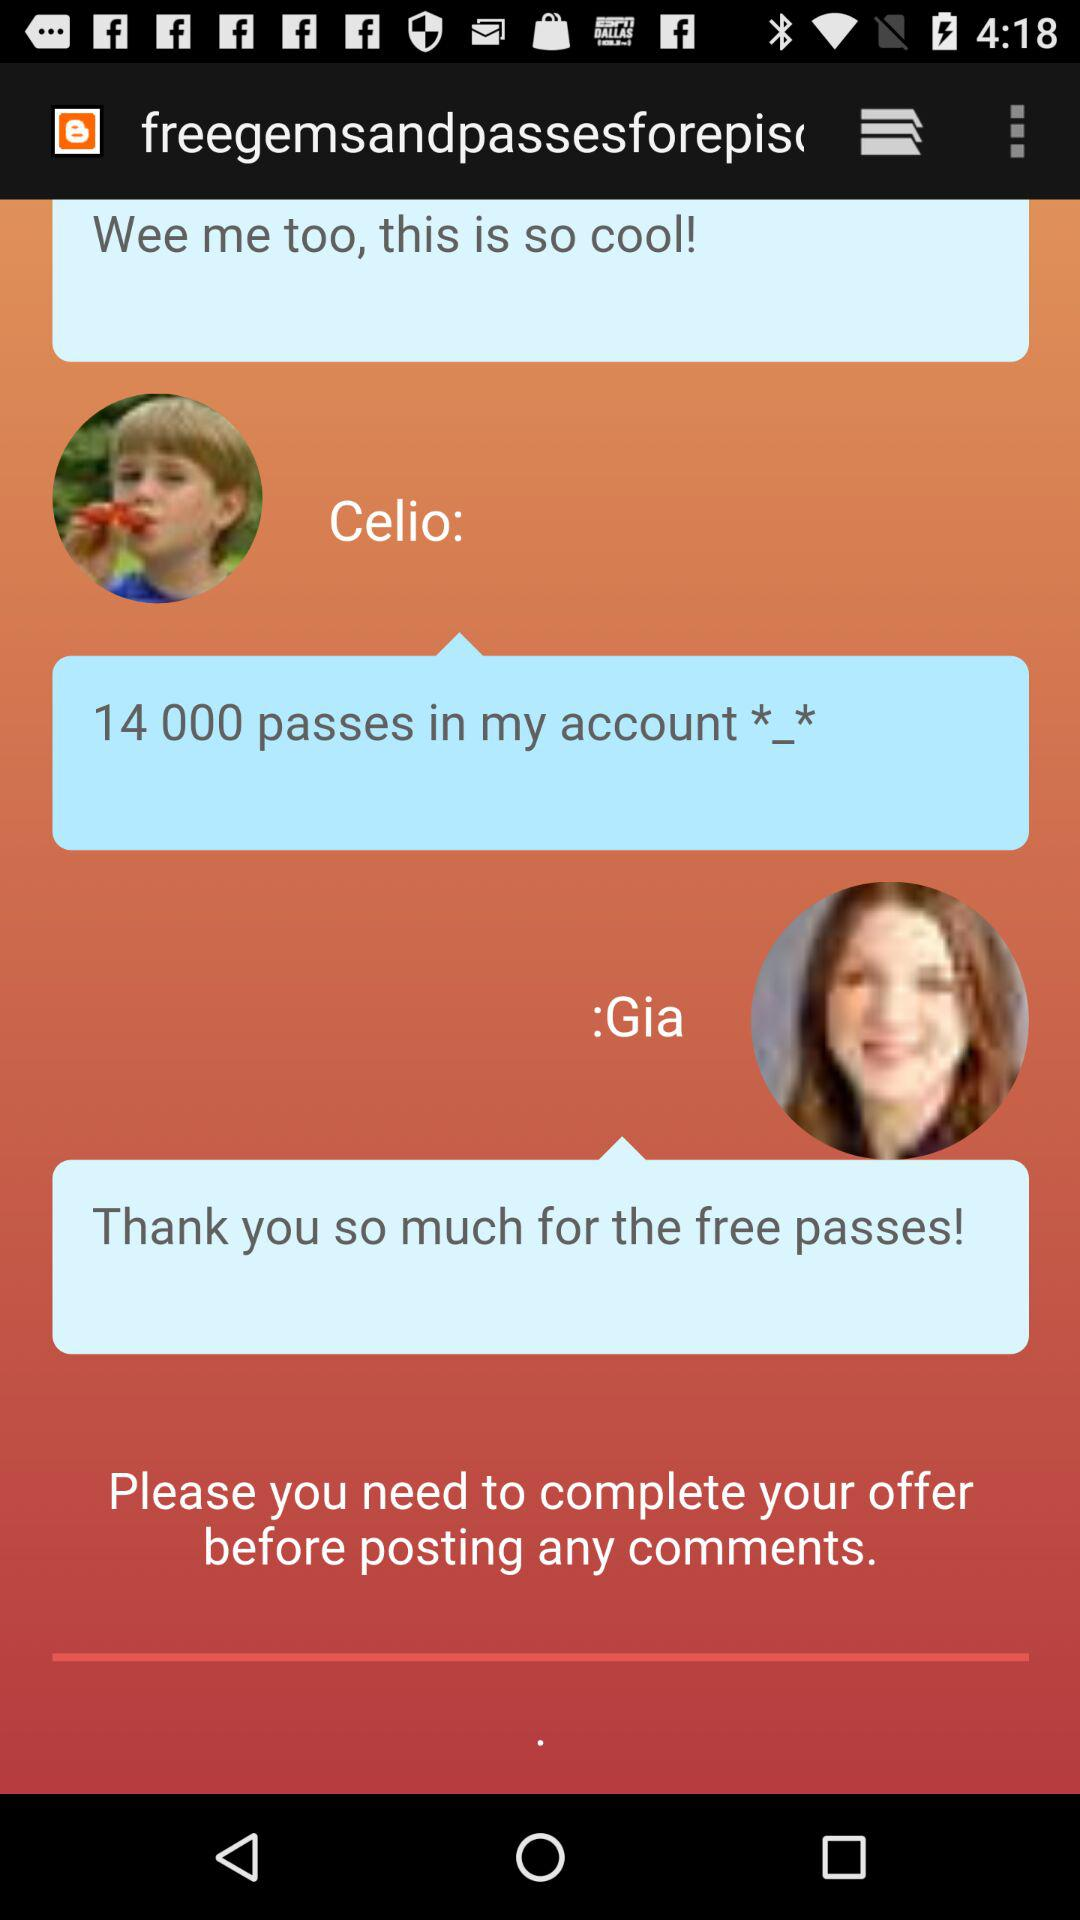How many more passes does Celio have in their account than Gia?
Answer the question using a single word or phrase. 14000 